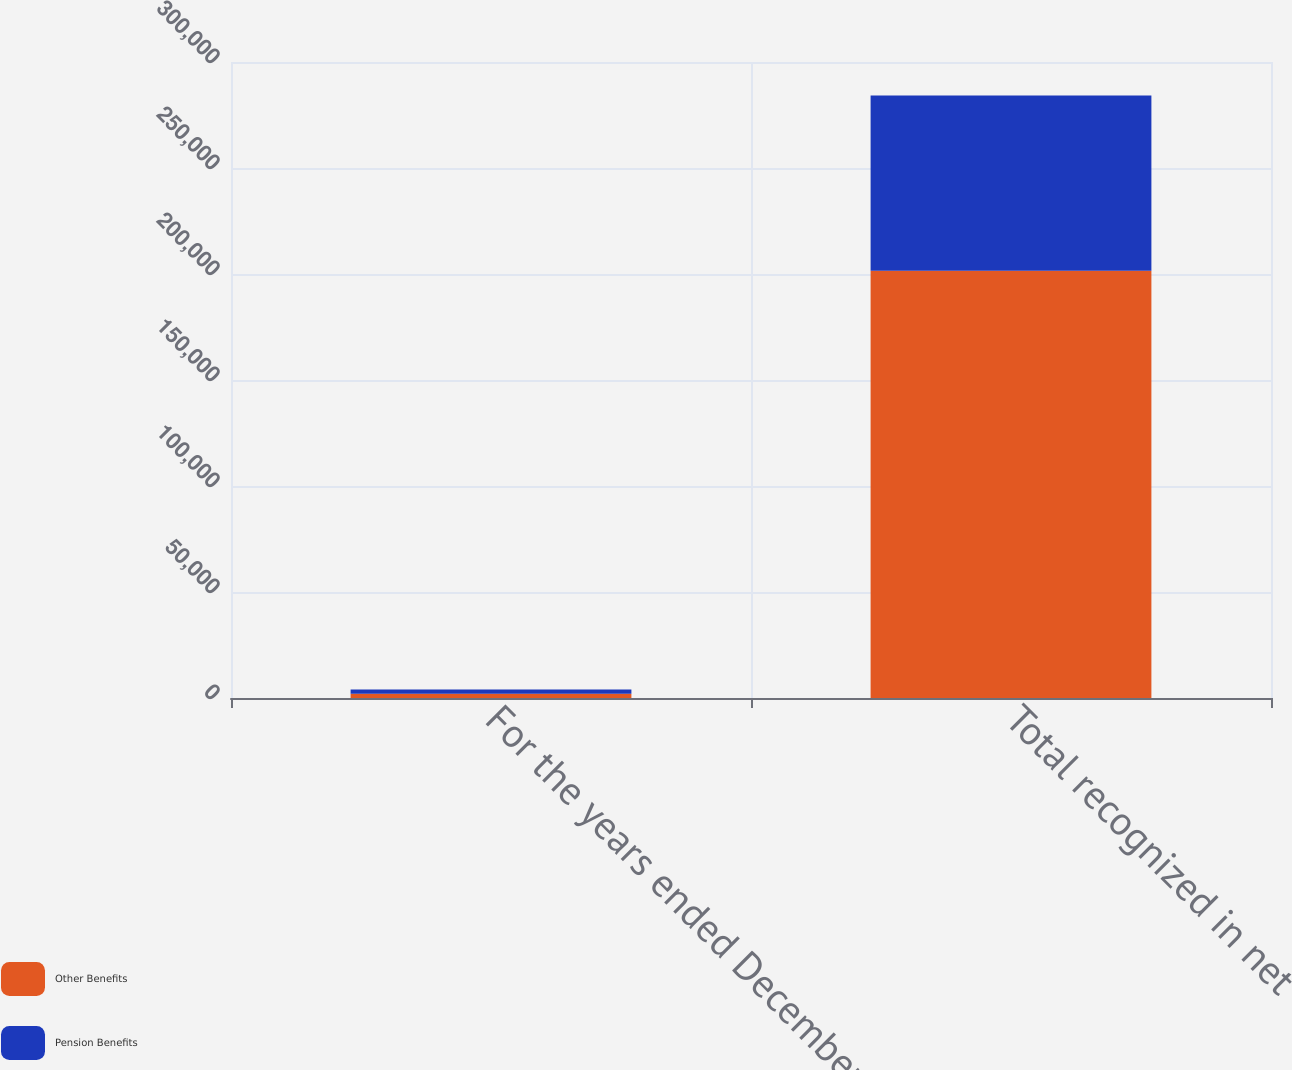<chart> <loc_0><loc_0><loc_500><loc_500><stacked_bar_chart><ecel><fcel>For the years ended December<fcel>Total recognized in net<nl><fcel>Other Benefits<fcel>2006<fcel>201502<nl><fcel>Pension Benefits<fcel>2006<fcel>82702<nl></chart> 